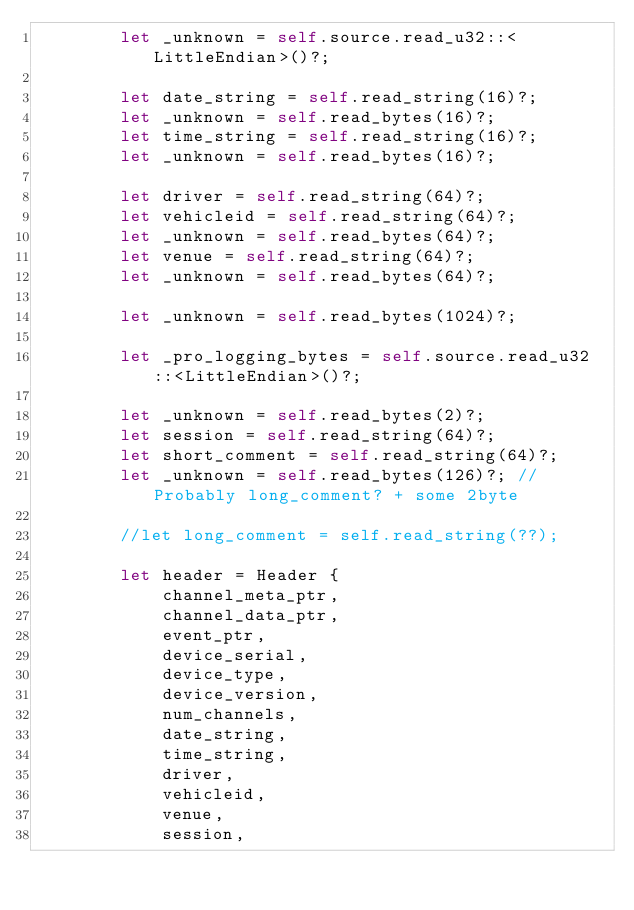Convert code to text. <code><loc_0><loc_0><loc_500><loc_500><_Rust_>        let _unknown = self.source.read_u32::<LittleEndian>()?;

        let date_string = self.read_string(16)?;
        let _unknown = self.read_bytes(16)?;
        let time_string = self.read_string(16)?;
        let _unknown = self.read_bytes(16)?;

        let driver = self.read_string(64)?;
        let vehicleid = self.read_string(64)?;
        let _unknown = self.read_bytes(64)?;
        let venue = self.read_string(64)?;
        let _unknown = self.read_bytes(64)?;

        let _unknown = self.read_bytes(1024)?;

        let _pro_logging_bytes = self.source.read_u32::<LittleEndian>()?;

        let _unknown = self.read_bytes(2)?;
        let session = self.read_string(64)?;
        let short_comment = self.read_string(64)?;
        let _unknown = self.read_bytes(126)?; // Probably long_comment? + some 2byte

        //let long_comment = self.read_string(??);

        let header = Header {
            channel_meta_ptr,
            channel_data_ptr,
            event_ptr,
            device_serial,
            device_type,
            device_version,
            num_channels,
            date_string,
            time_string,
            driver,
            vehicleid,
            venue,
            session,</code> 